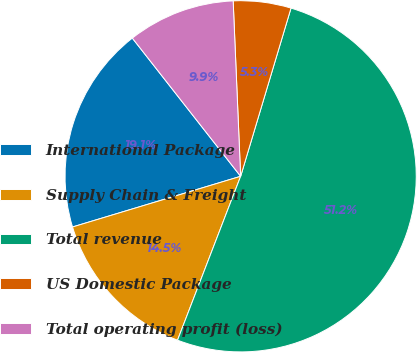<chart> <loc_0><loc_0><loc_500><loc_500><pie_chart><fcel>International Package<fcel>Supply Chain & Freight<fcel>Total revenue<fcel>US Domestic Package<fcel>Total operating profit (loss)<nl><fcel>19.08%<fcel>14.49%<fcel>51.22%<fcel>5.31%<fcel>9.9%<nl></chart> 